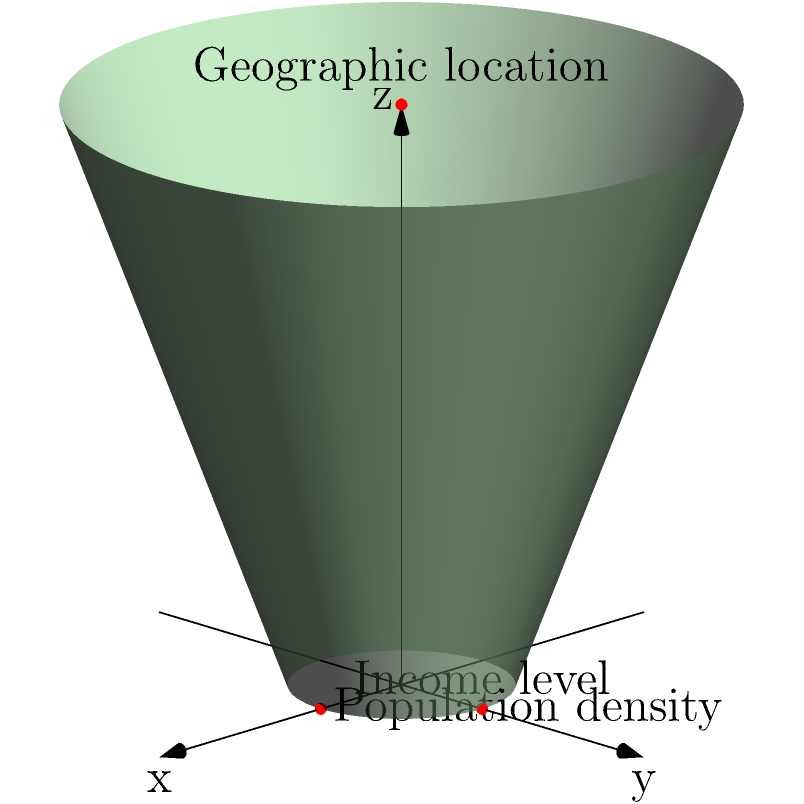In the cylindrical coordinate system shown, we represent Mexican cities using three parameters: $r$ (distance from the z-axis), $\theta$ (angle in the xy-plane), and $z$ (height). If $r$ represents population density, $\theta$ represents geographic location (longitude), and $z$ represents income level, what economic insight can be gained by analyzing the distribution of cities in this coordinate system? To answer this question, let's break down the analysis step-by-step:

1. Interpretation of coordinates:
   - $r$: Population density (distance from z-axis)
   - $\theta$: Geographic location/longitude (angle in xy-plane)
   - $z$: Income level (height)

2. Distribution analysis:
   a) Radial distribution ($r$):
      - Cities closer to the z-axis have lower population density
      - Cities farther from the z-axis have higher population density

   b) Angular distribution ($\theta$):
      - Represents the geographic spread of cities across Mexico

   c) Vertical distribution ($z$):
      - Lower z-values indicate lower income levels
      - Higher z-values indicate higher income levels

3. Economic insights:
   a) Correlation between population density and income:
      - If cities tend to cluster in the upper-outer region of the cylinder, it suggests a positive correlation between population density and income levels.
      - If cities are evenly distributed vertically, it indicates no strong correlation between population density and income.

   b) Geographic income disparities:
      - Analyzing the distribution along $\theta$ at different z-levels can reveal regional income inequalities.

   c) Urbanization patterns:
      - Clusters of high-r, high-z points may indicate major urban centers with high population density and income.

   d) Economic development zones:
      - Areas with consistently high z-values across different $\theta$ could represent economically developed regions.

   e) Policy targeting:
      - Identifying areas with low z-values but high r-values could help target economic policies to densely populated, low-income areas.

4. Policy implications:
   - This visualization can guide resource allocation, infrastructure development, and targeted economic interventions based on the spatial distribution of population density and income levels across different geographic locations.
Answer: Correlation between population density, income, and geographic location; identification of economic disparities and development patterns; guidance for targeted policy interventions. 